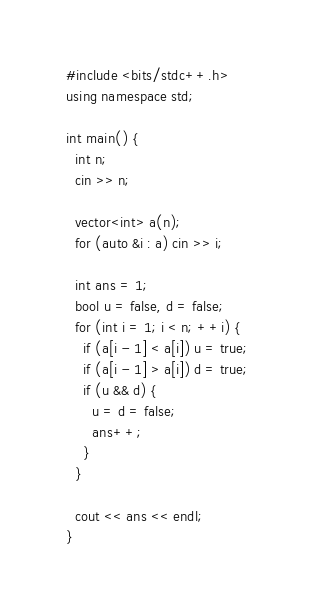Convert code to text. <code><loc_0><loc_0><loc_500><loc_500><_C++_>#include <bits/stdc++.h>
using namespace std;

int main() {
  int n;
  cin >> n;

  vector<int> a(n);
  for (auto &i : a) cin >> i;

  int ans = 1;
  bool u = false, d = false;
  for (int i = 1; i < n; ++i) {
    if (a[i - 1] < a[i]) u = true;
    if (a[i - 1] > a[i]) d = true;
    if (u && d) {
      u = d = false;
      ans++;
    }
  }

  cout << ans << endl;
}
</code> 